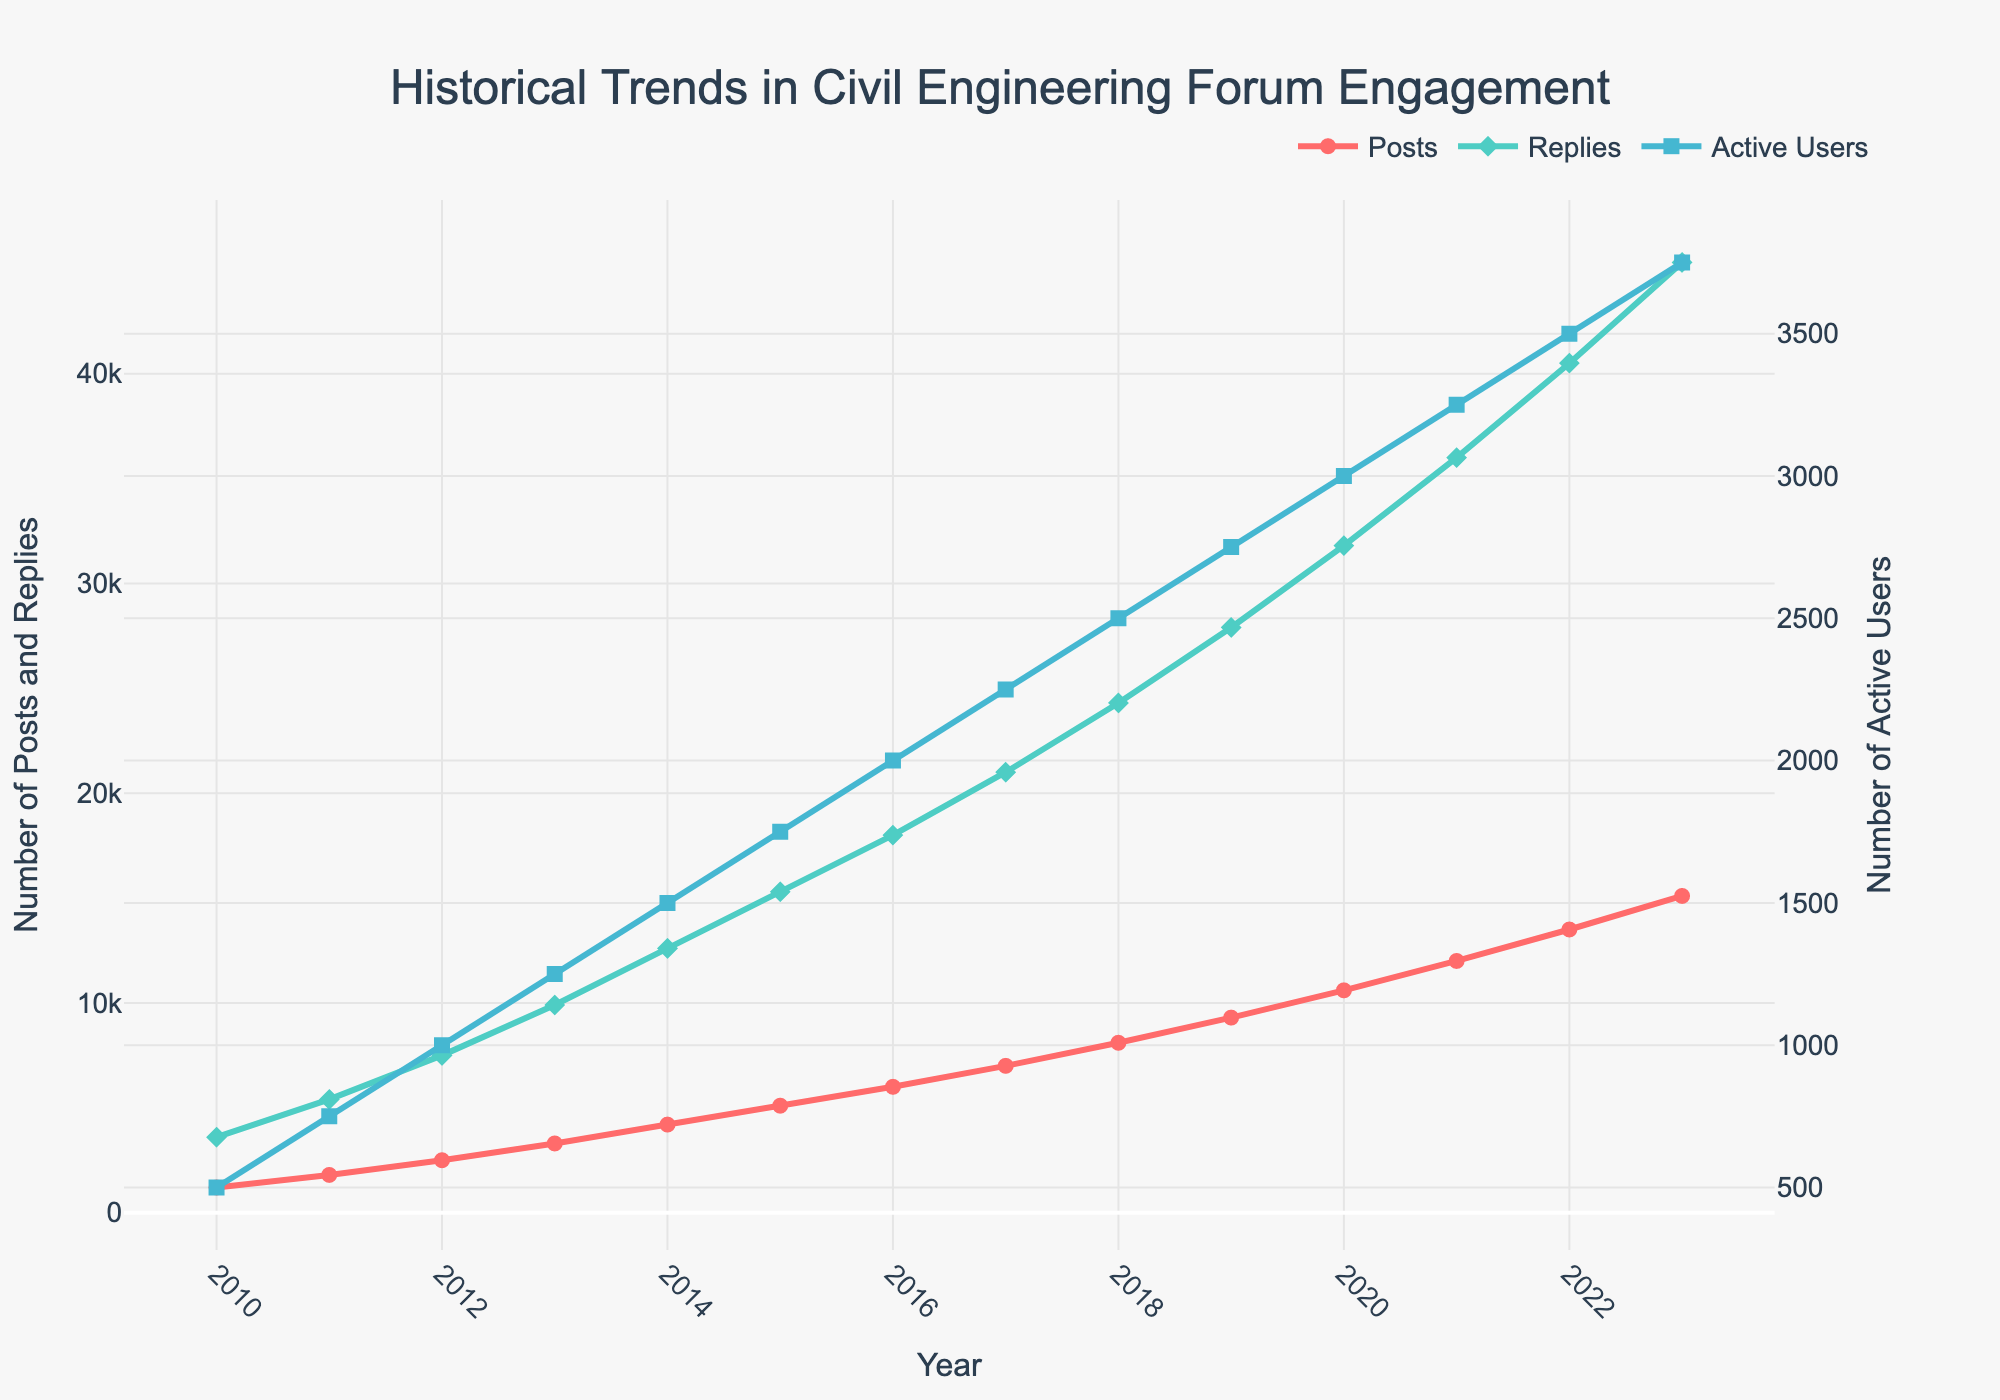What's the trend in the number of posts from 2010 to 2023? To understand the trend, examine the line representing the number of posts over the years. The number of posts consistently increased each year from 1200 in 2010 to 15100 in 2023.
Answer: Increasing Between replies and active users, which metric had a greater absolute increase from 2010 to 2023? Calculate the absolute increase for both metrics. Replies increased from 3600 to 45300 (45300 - 3600 = 41700), and active users increased from 500 to 3750 (3750 - 500 = 3250). Compare the increases: 41700 for replies is greater than 3250 for active users.
Answer: Replies Which year saw the first time the number of active users reached or exceeded 3000? Locate the point on the line representing active users where the value reaches or exceeds 3000. This occurs in 2020 when active users are 3000.
Answer: 2020 How does the growth rate of posts from 2011 to 2013 compare to the growth rate of active users over the same period? Calculate the growth rates. For posts: (3300 - 1800) / 1800 = 0.8333 or 83.33%. For active users: (1250 - 750) / 750 = 0.6667 or 66.67%. The growth rate of posts (83.33%) is higher than that of active users (66.67%).
Answer: Higher for posts What is the approximate visual relationship between the lines for posts and replies in terms of color and shape? Assess the visual attributes: The line for posts is red with circle markers, and the line for replies is green with diamond markers.
Answer: Red with circles for posts, green with diamonds for replies Between 2015 and 2020, which metric saw the most significant increase in absolute numbers? Calculate the increases: Posts from 5100 to 10600 (5100 increase), replies from 15300 to 31800 (16500 increase), and active users from 1750 to 3000 (1250 increase). Replies had the most significant increase of 16500.
Answer: Replies What's the average number of replies per year from 2010 to 2023? Sum the number of replies for each year and divide by the number of years. Total replies = (3600 + 5400 + ... + 45300) = 225900. Number of years = 14. Average = 225900 / 14 = 16135.71.
Answer: 16135.71 In which year did the number of posts first exceed 5000? Locate the year where the posts line first crosses the 5000 mark, which is 2015.
Answer: 2015 When comparing the growth rates between 2015 and 2023, which metric grew the fastest? Calculate the relative growth rates. For posts: (15100 - 5100) / 5100 = 1.9616 or 196.16%. For replies: (45300 - 15300) / 15300 = 1.9608 or 196.08%. For active users: (3750 - 1750) / 1750 = 1.1429 or 114.29%. Posts grew slightly faster (196.16%) than replies (196.08%) and much faster than active users (114.29%).
Answer: Posts What is the difference in the number of active users between 2012 and 2018? Subtract the number of active users in 2012 from the number in 2018: 2500 - 1000 = 1500.
Answer: 1500 